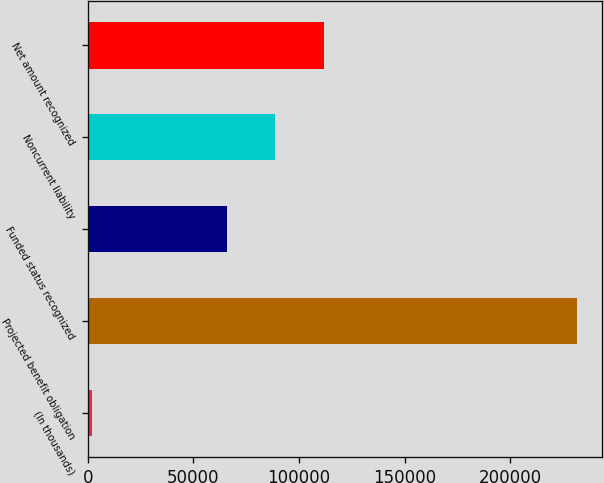Convert chart to OTSL. <chart><loc_0><loc_0><loc_500><loc_500><bar_chart><fcel>(In thousands)<fcel>Projected benefit obligation<fcel>Funded status recognized<fcel>Noncurrent liability<fcel>Net amount recognized<nl><fcel>2019<fcel>231677<fcel>65657<fcel>88622.8<fcel>111589<nl></chart> 